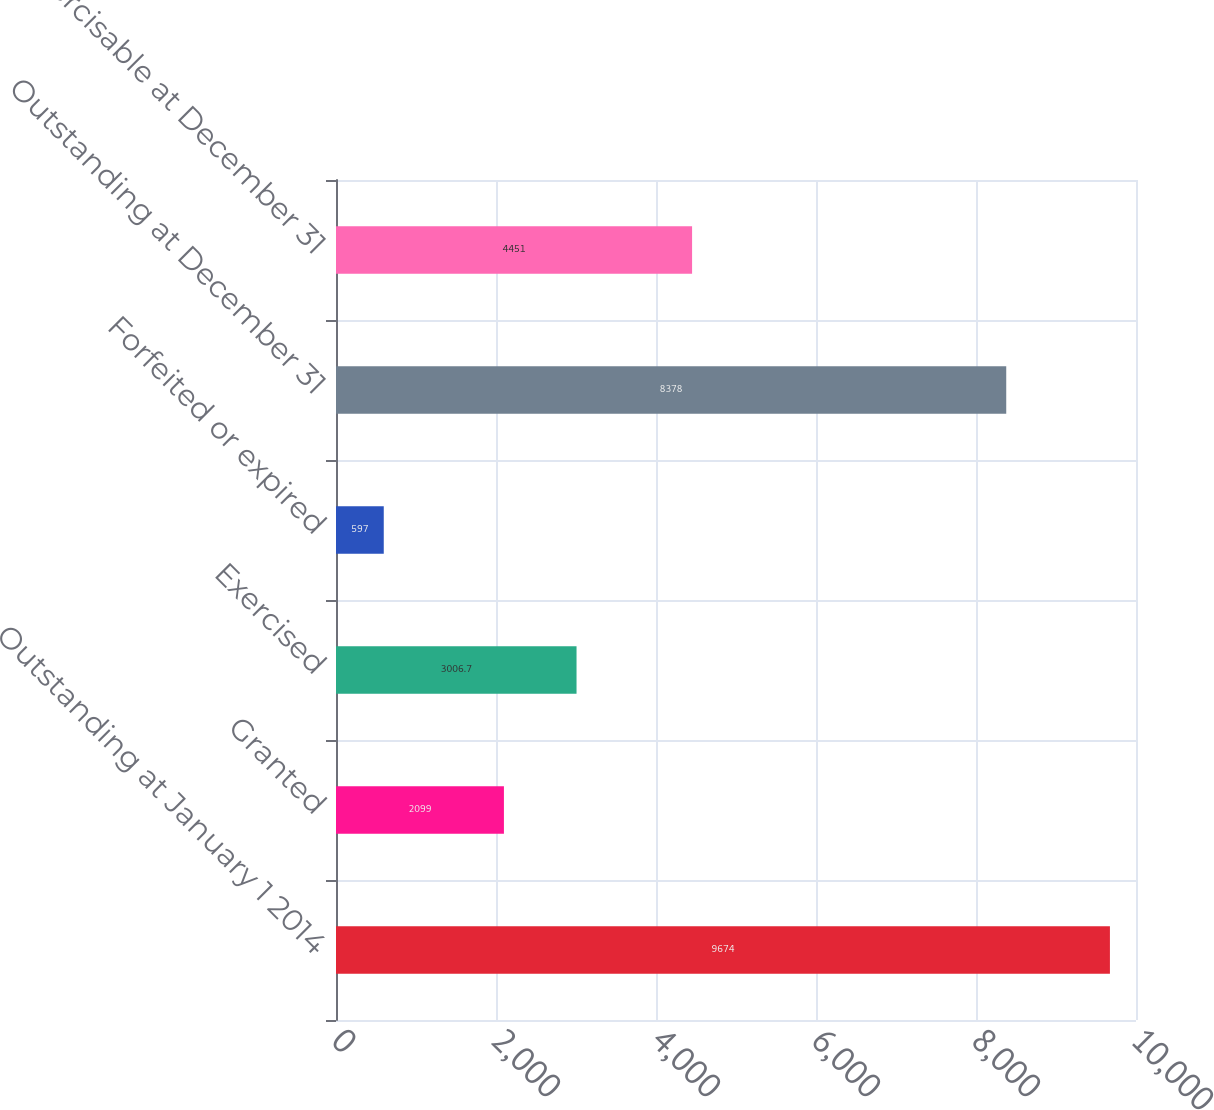Convert chart to OTSL. <chart><loc_0><loc_0><loc_500><loc_500><bar_chart><fcel>Outstanding at January 1 2014<fcel>Granted<fcel>Exercised<fcel>Forfeited or expired<fcel>Outstanding at December 31<fcel>Exercisable at December 31<nl><fcel>9674<fcel>2099<fcel>3006.7<fcel>597<fcel>8378<fcel>4451<nl></chart> 